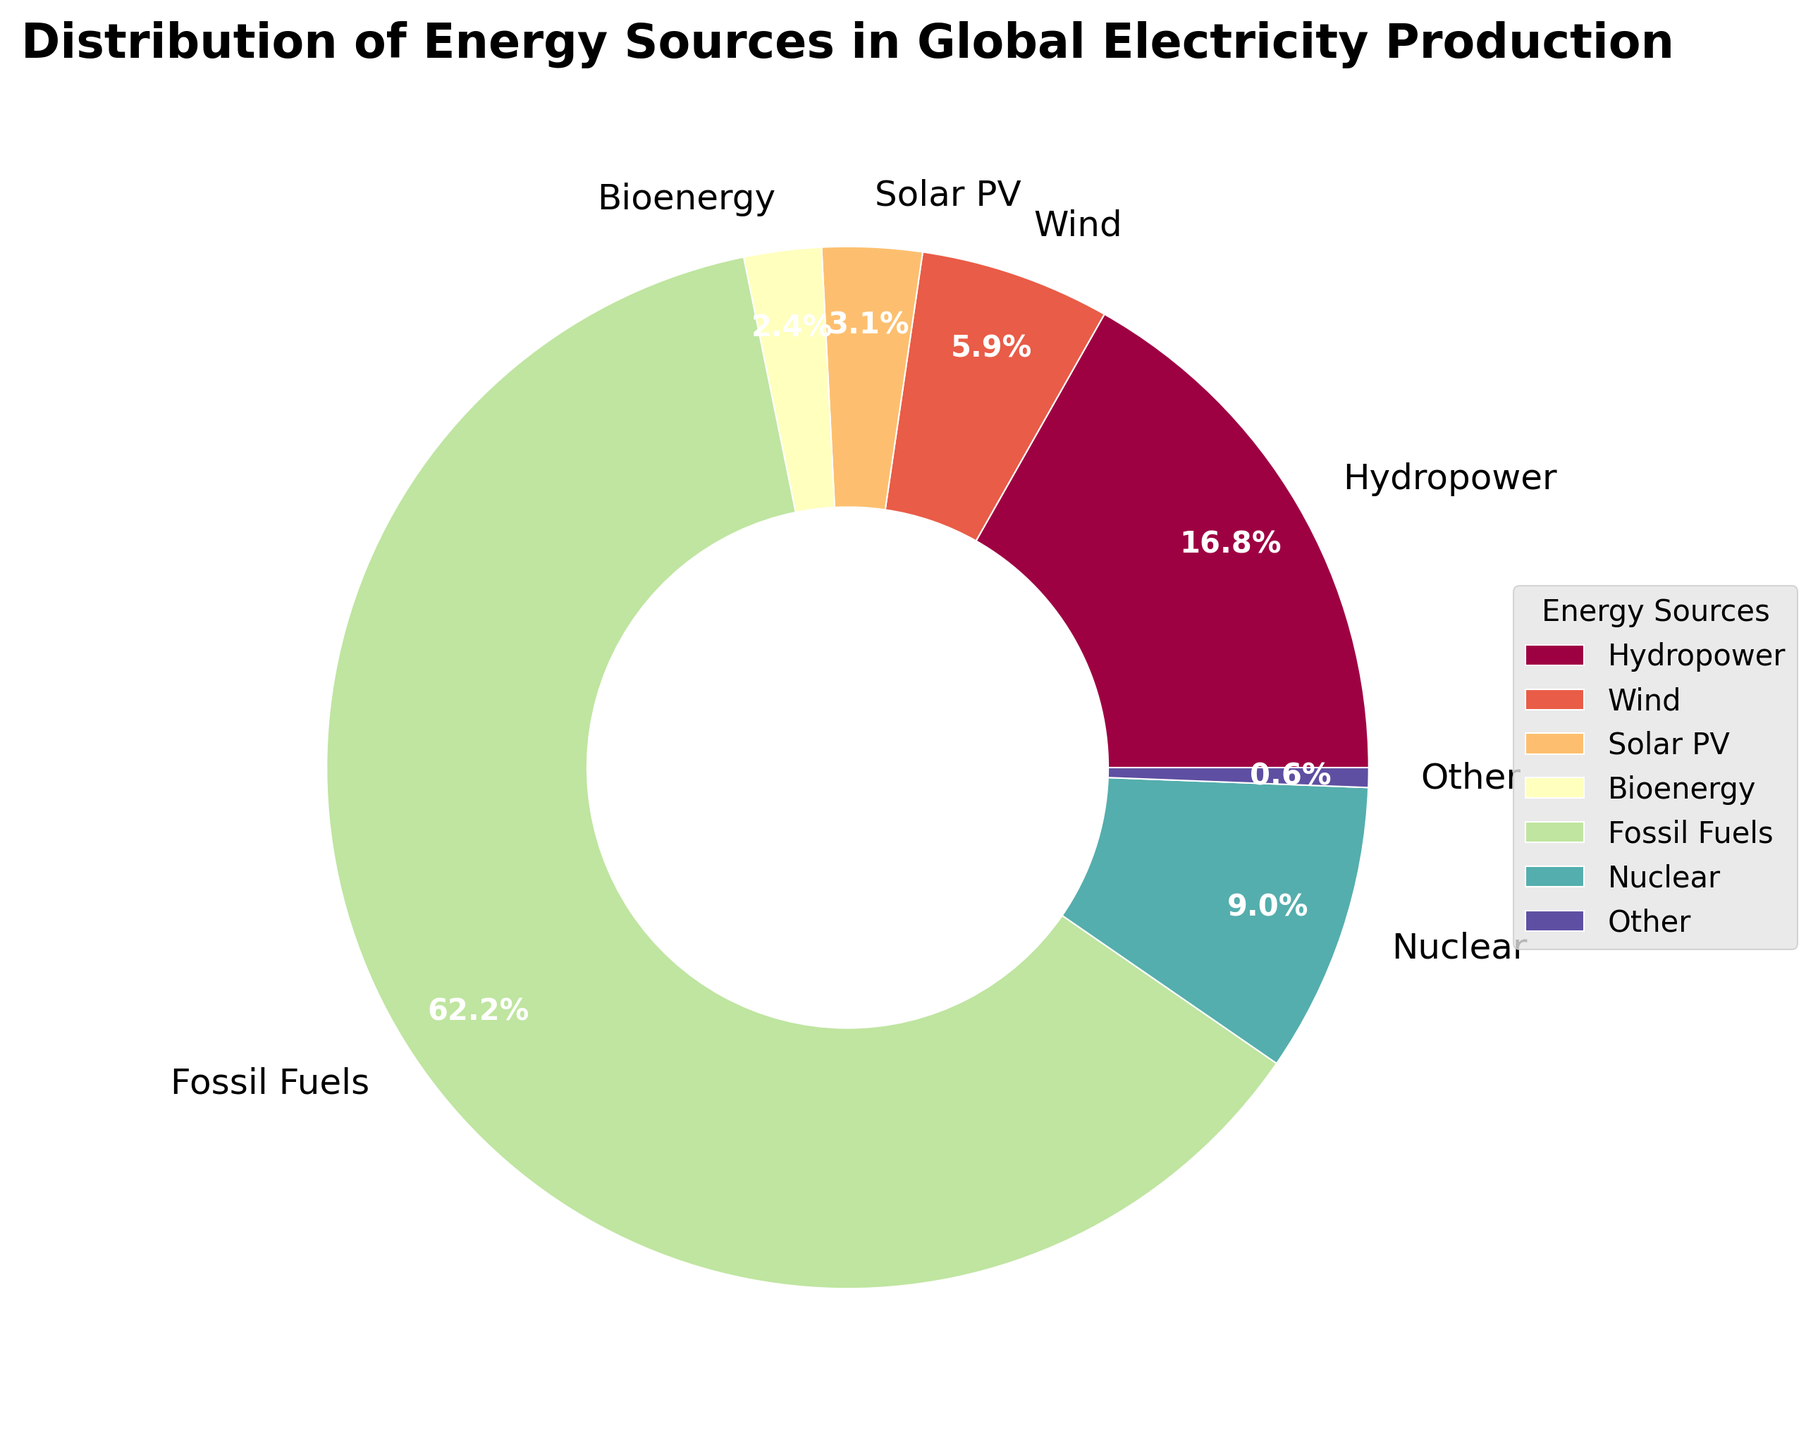What is the percentage of Hydropower contribution to global electricity production? The slice labeled 'Hydropower' shows a percentage of 16.8%.
Answer: 16.8% How much larger is the fossil fuel contribution compared to wind energy? The percentage for fossil fuels is 62.19%, and for wind, it is 5.9%. The difference is 62.19% - 5.9% = 56.29%.
Answer: 56.29% What are the total contributions of solar PV and concentrated solar power combined? Solar PV contributes 3.1% and concentrated solar power contributes 0.1%. Combined, they contribute 3.1% + 0.1% = 3.2%.
Answer: 3.2% Which renewable energy source apart from hydropower has the highest percentage contribution? The renewable energy sources apart from hydropower are wind (5.9%), solar PV (3.1%), bioenergy (2.4%), geothermal (0.5%), concentrated solar power (0.1%), and ocean energy (0.01%). Among them, wind has the highest contribution with 5.9%.
Answer: Wind What is the contribution of all renewable energy sources grouped under 'Other'? The 'Other' category includes contributions less than 1%: geothermal (0.5%), concentrated solar power (0.1%), and ocean energy (0.01%). Their total contribution is 0.5% + 0.1% + 0.01% = 0.61%.
Answer: 0.61% How does the contribution of nuclear energy compare to the combined renewable energy sources excluding hydropower? Nuclear contributes 9%. The combined contribution of renewables excluding hydropower is wind (5.9%) + solar PV (3.1%) + bioenergy (2.4%) + other (0.61%) = 12.01%. Thus, renewables excluding hydropower contribute more than nuclear energy by 12.01% - 9% = 3.01%.
Answer: 3.01% Rank the contributions of each energy source from highest to lowest. The contributions are as follows: Fossil Fuels (62.19%), Hydropower (16.8%), Nuclear (9%), Wind (5.9%), Solar PV (3.1%), Bioenergy (2.4%), Other (0.61%).
Answer: Fossil Fuels, Hydropower, Nuclear, Wind, Solar PV, Bioenergy, Other What proportion of the chart is dedicated to energy sources contributing less than 5%? The energy sources contributing less than 5% are solar PV (3.1%), bioenergy (2.4%), geothermal (0.5%), concentrated solar power (0.1%), and ocean energy (0.01%). Together they make up 3.1% + 2.4% + 0.5% + 0.1% + 0.01% = 6.11%.
Answer: 6.11% What percentage of the energy sources contribution is visualized with a red slice? Without visual specifics, the largest contributions are most likely assigned to easily distinguishable colors. Typically, the largest slice (fossil fuels at 62.19%) is red in such charts for emphasis.
Answer: 62.19% If geothermal and bioenergy were combined into a single category, what would the new percentage be? Geothermal contributes 0.5% and bioenergy contributes 2.4%. Combined, they would contribute 0.5% + 2.4% = 2.9%.
Answer: 2.9% 